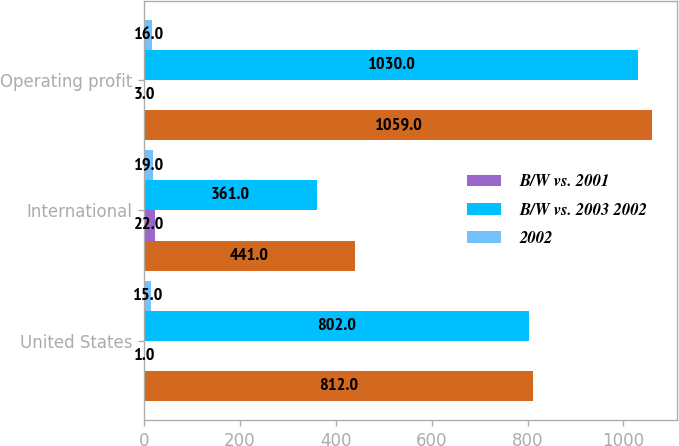Convert chart to OTSL. <chart><loc_0><loc_0><loc_500><loc_500><stacked_bar_chart><ecel><fcel>United States<fcel>International<fcel>Operating profit<nl><fcel>nan<fcel>812<fcel>441<fcel>1059<nl><fcel>B/W vs. 2001<fcel>1<fcel>22<fcel>3<nl><fcel>B/W vs. 2003 2002<fcel>802<fcel>361<fcel>1030<nl><fcel>2002<fcel>15<fcel>19<fcel>16<nl></chart> 